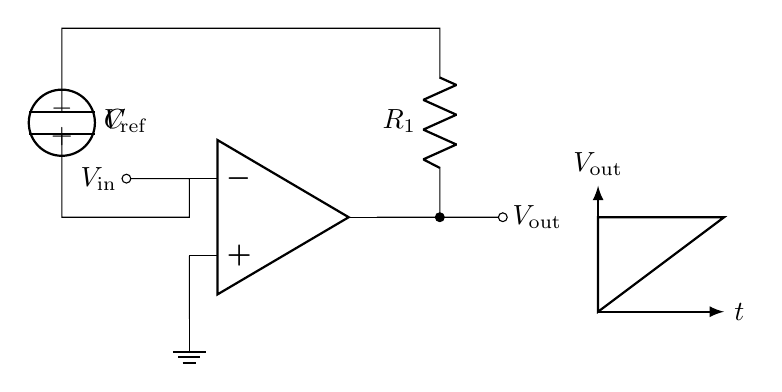What is the function of the op-amp in this circuit? The op-amp amplifies the difference in voltage between its inverting and non-inverting terminals, enabling the relaxation oscillator to generate sawtooth waveforms.
Answer: Amplification What component is responsible for the timing in the oscillator? The timing in the oscillator is primarily determined by the resistor and capacitor connected to the op-amp. They set the charge and discharge cycle that creates the sawtooth waveform.
Answer: Resistor and Capacitor What is the reference voltage in this circuit? The reference voltage is indicated as V ref, which serves as a baseline potential for the op-amp to compare against when generating output.
Answer: V ref How would increasing the capacitance affect the output waveform frequency? Increasing the capacitance would decrease the frequency of the sawtooth waveform, as longer charging and discharging times would result from a larger capacitor.
Answer: Decrease frequency What type of waveform is produced at the output? The output waveform produced by this relaxation oscillator circuit is a sawtooth waveform, characterized by a linear rise and a rapid fall.
Answer: Sawtooth What happens if R1 is decreased in value? Decreasing the value of R1 would increase the frequency of the output waveform, as the charging time of the capacitor would decrease, leading to a faster cycle.
Answer: Increase frequency What is the role of the capacitor in the circuit? The capacitor stores charge and dictates the timing of the oscillator, determining how quickly the output waveform rises and falls.
Answer: Timing 